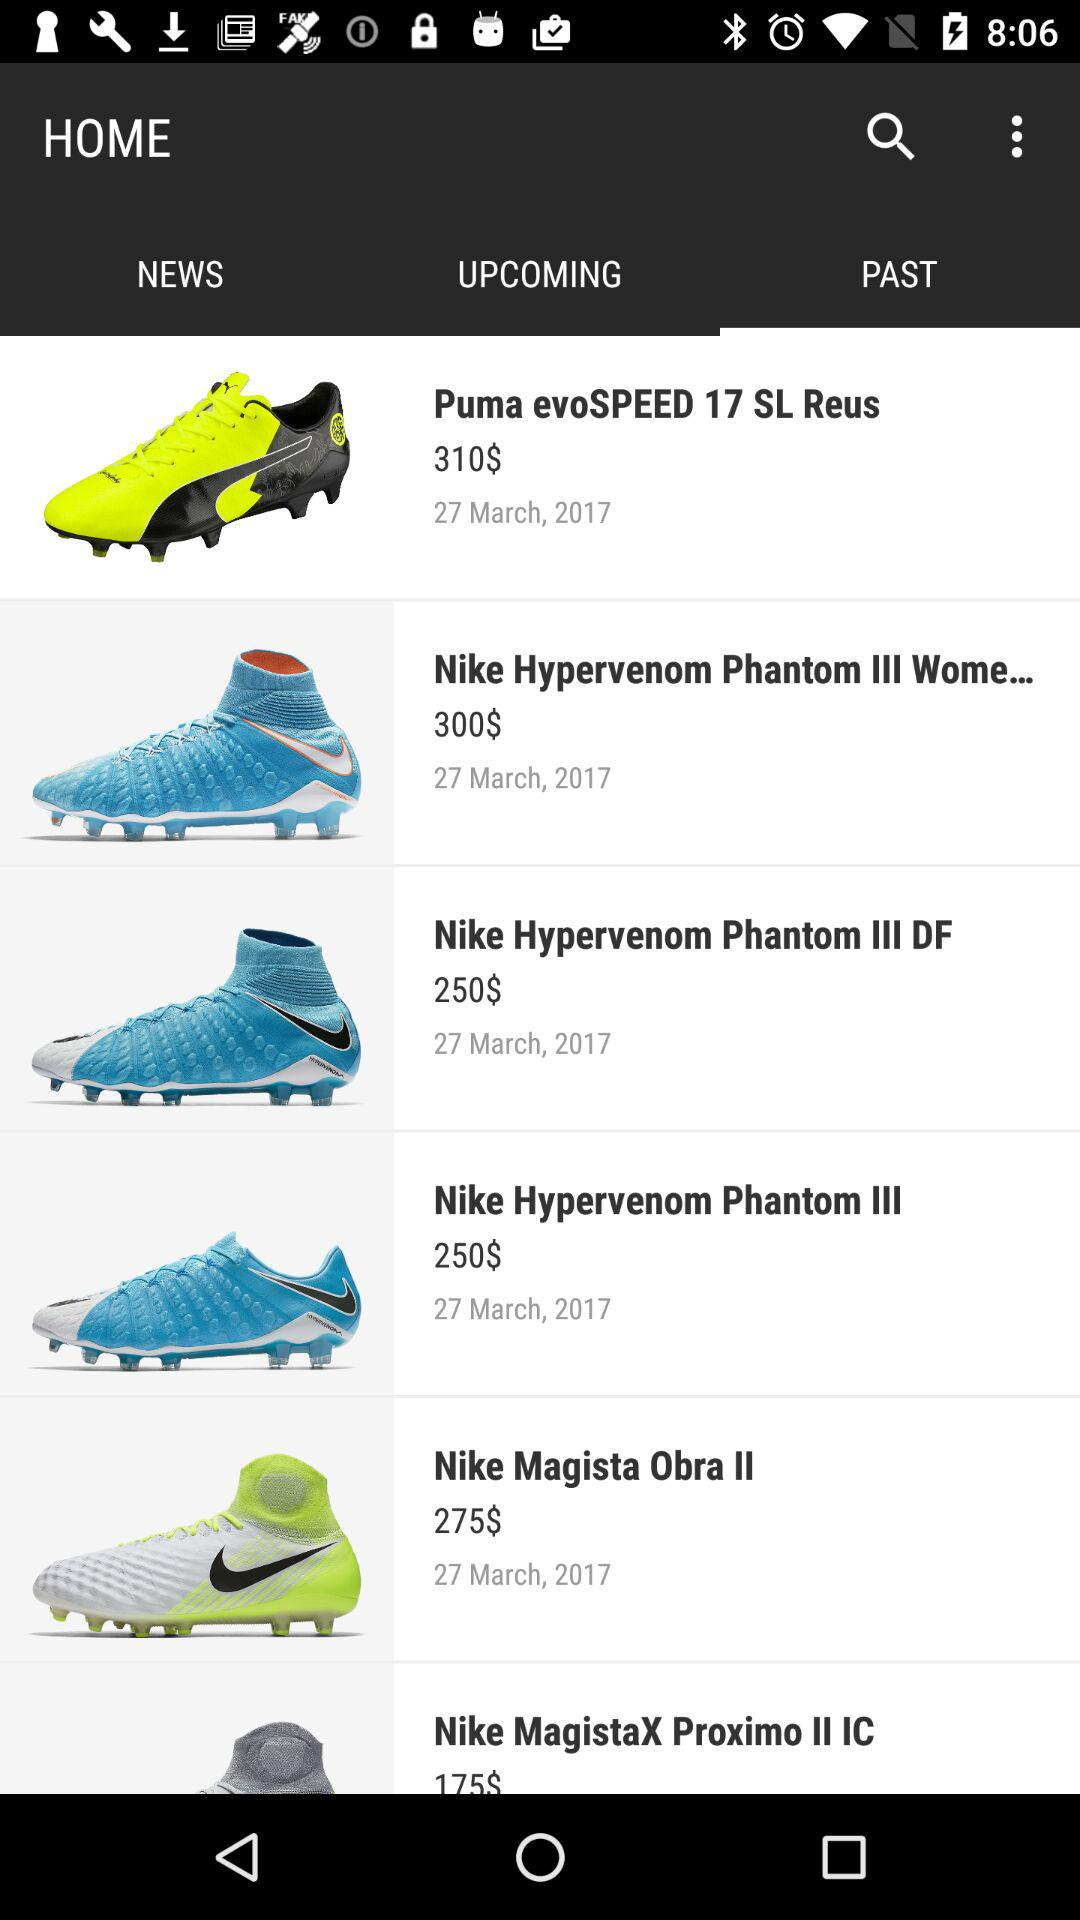What is the price of the "Nike Magista Obra II"? The price of the "Nike Magista Obra II" is $275. 